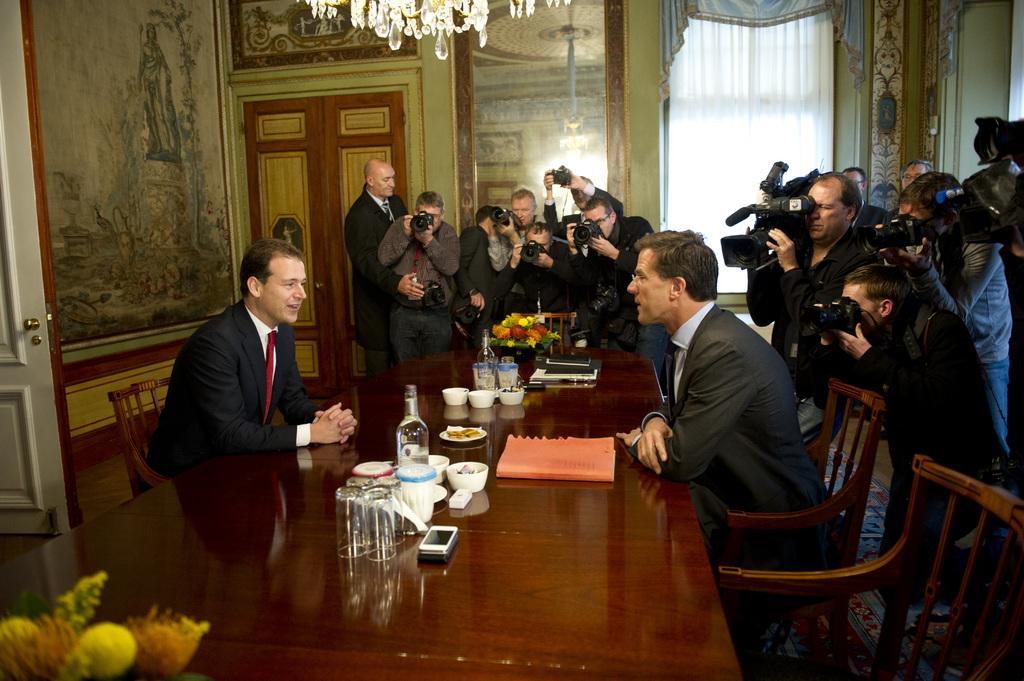How would you summarize this image in a sentence or two? in this picture to the left side there is a man with black jacket, red tie and white shirt is sitting. In front of him there is another person with black jacket, blue shirt and blue tie is sitting. In between them there is a table with glass, bottle bowl, cup, plate , mobile, flower vase and a book. To the table corner there are group of people standing and taking picture by holding cameras in their hand. To the right there are another group of people taking video graph. To the right side there is a wall with curtain. and to the left side there is a door, beside the door there is a frame.. And in the middle there is a mirror. 